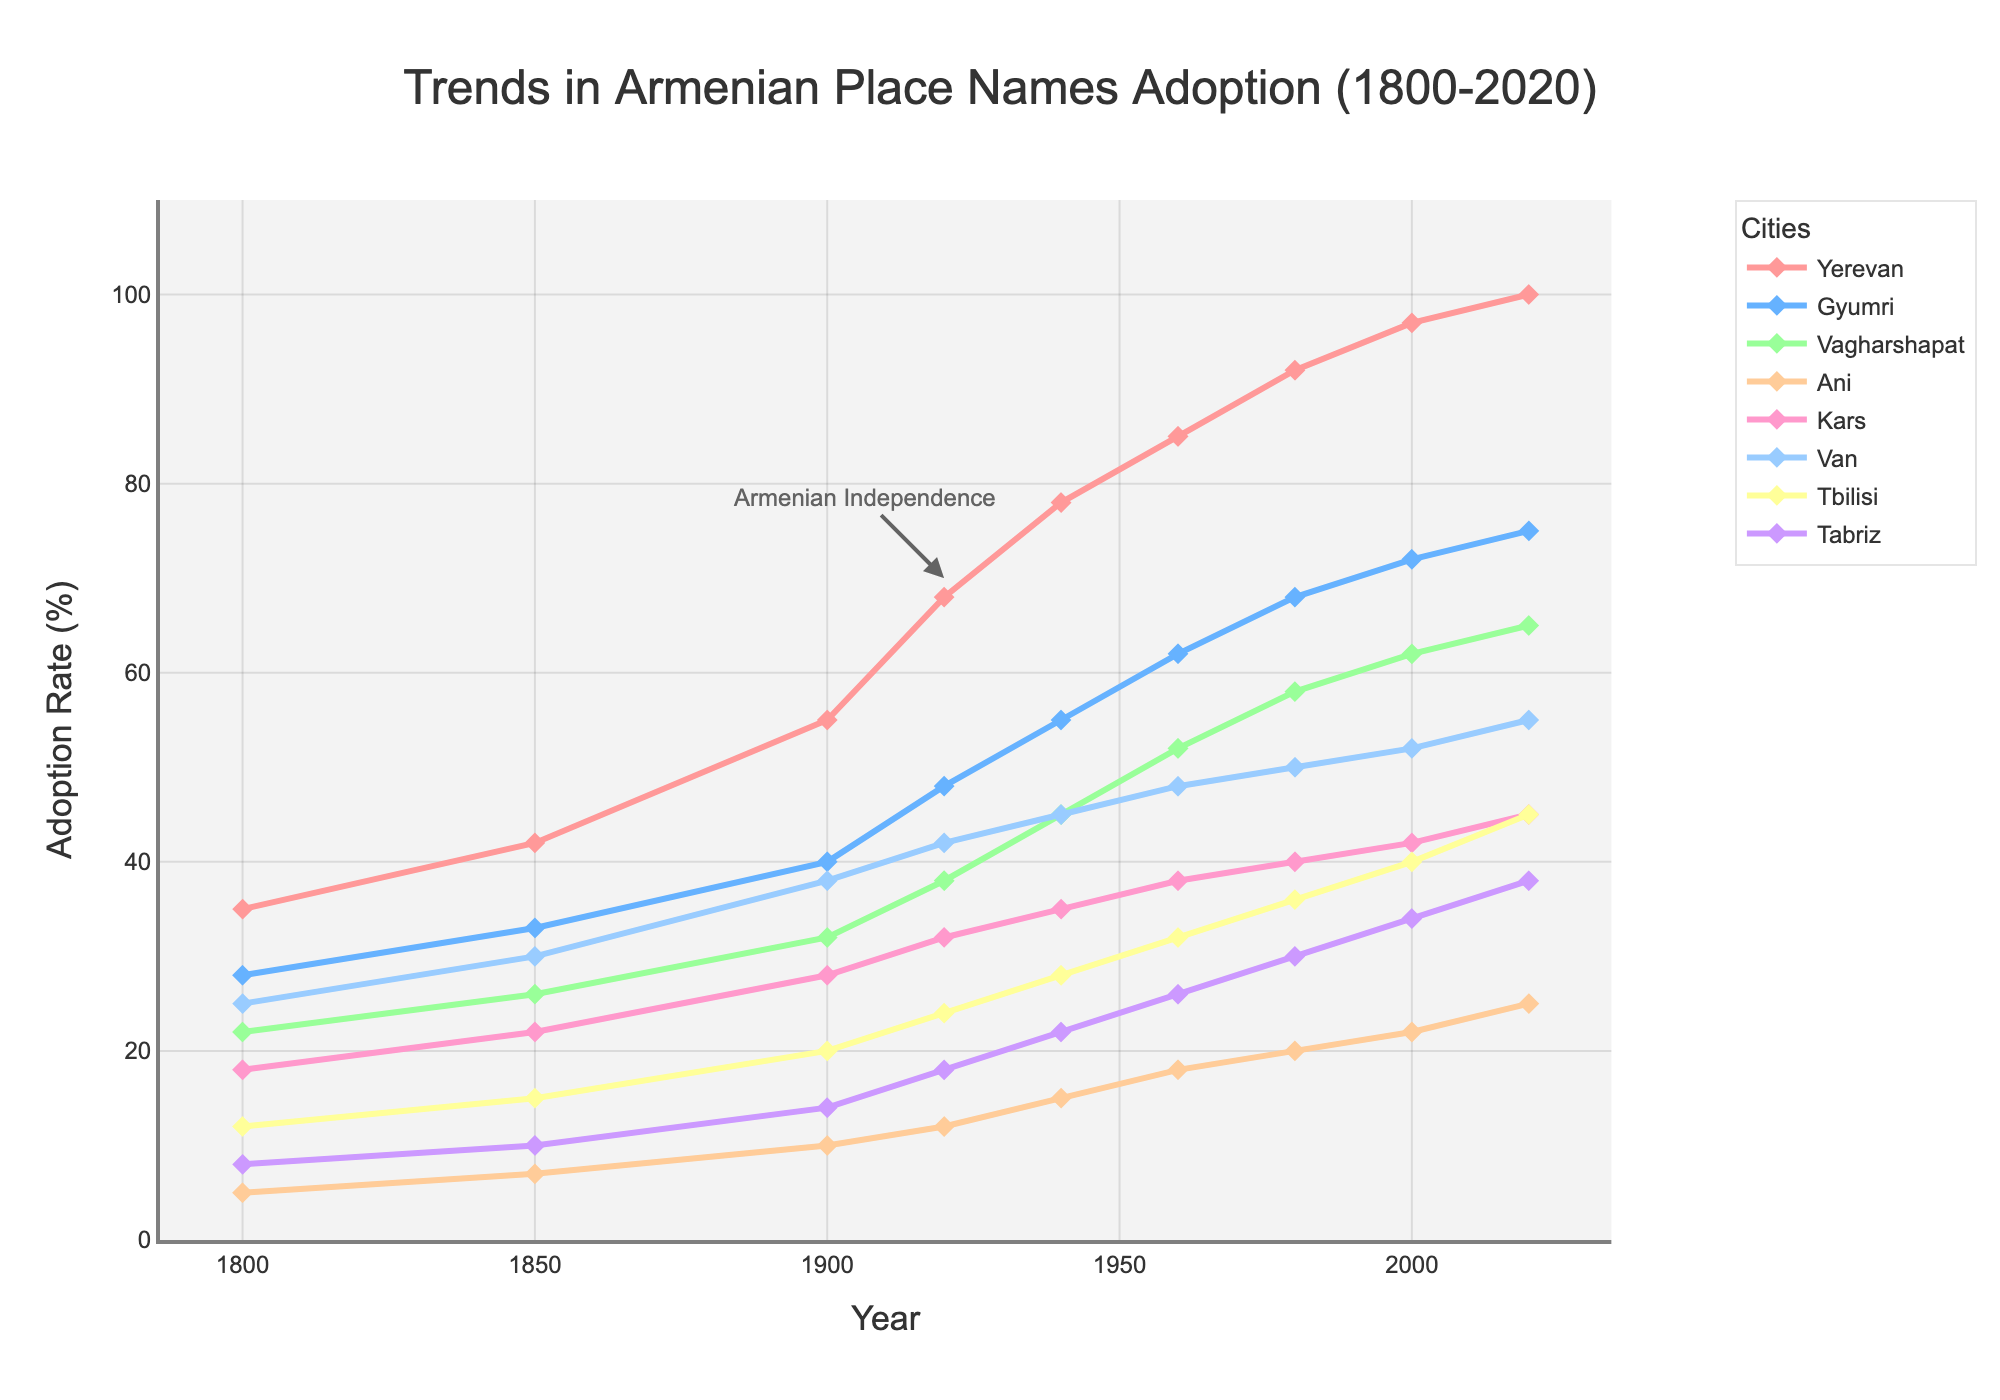How did the adoption rates for Yerevan and Tbilisi compare in 1940? From the figure, in 1940, Yerevan had an adoption rate of 78%, and Tbilisi had an adoption rate of 28%. Comparing these two values shows Yerevan had a significantly higher adoption rate than Tbilisi.
Answer: Yerevan's adoption rate was higher Which city had the highest adoption rate in 2020, and what was the rate? By observing the lines with markers for 2020, it’s clear that Yerevan, represented in red, had the highest adoption rate at that point in time. The value for Yerevan in 2020 is 100%.
Answer: Yerevan, 100% What was the difference in adoption rates between Van and Ani in 1920? For 1920, the adoption rate for Van was 42%, and for Ani, it was 12%. The difference is calculated as 42% - 12%.
Answer: 30% In which year did Gyumri's adoption rate first exceed 60%? Tracing the line for Gyumri, which is depicted in light blue, Gyumri first exceeded 60% adoption rate in the year 1960, where the rate is shown as 62%.
Answer: 1960 Which cities showed an increase in adoption rates between 2000 and 2020? Looking at the endpoints for 2000 and 2020 for each city:
- Yerevan: 97% to 100%
- Gyumri: 72% to 75%
- Vagharshapat: 62% to 65%
- Ani: 22% to 25%
- Kars: 42% to 45%
- Van: 52% to 55%
- Tbilisi: 40% to 45%
- Tabriz: 34% to 38%
All cities show an increase.
Answer: All cities What is the average adoption rate for Kars from 1800 to 2020? To find the average, sum up the Kars adoption rates for each year (18 + 22 + 28 + 32 + 35 + 38 + 40 + 42 + 45 = 300) and divide by the number of years (9). The calculation gives 300 / 9 = 33.33%.
Answer: 33.33% What significant event is annotated on the chart, and in which year does it occur? The chart includes an annotation marking the event "Armenian Independence," which occurs in 1920. This is highlighted near the year 1920.
Answer: Armenian Independence, 1920 